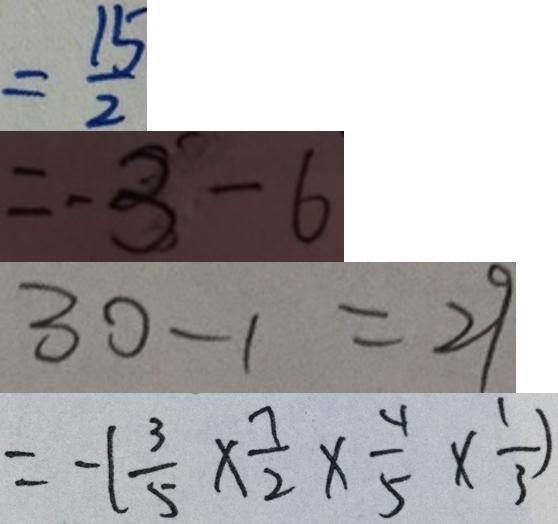<formula> <loc_0><loc_0><loc_500><loc_500>= \frac { 1 5 } { 2 } 
 = - 3 - 6 
 3 0 - 1 = 2 9 
 = - ( \frac { 3 } { 5 } \times \frac { 7 } { 2 } \times \frac { 4 } { 5 } \times \frac { 1 } { 3 } )</formula> 